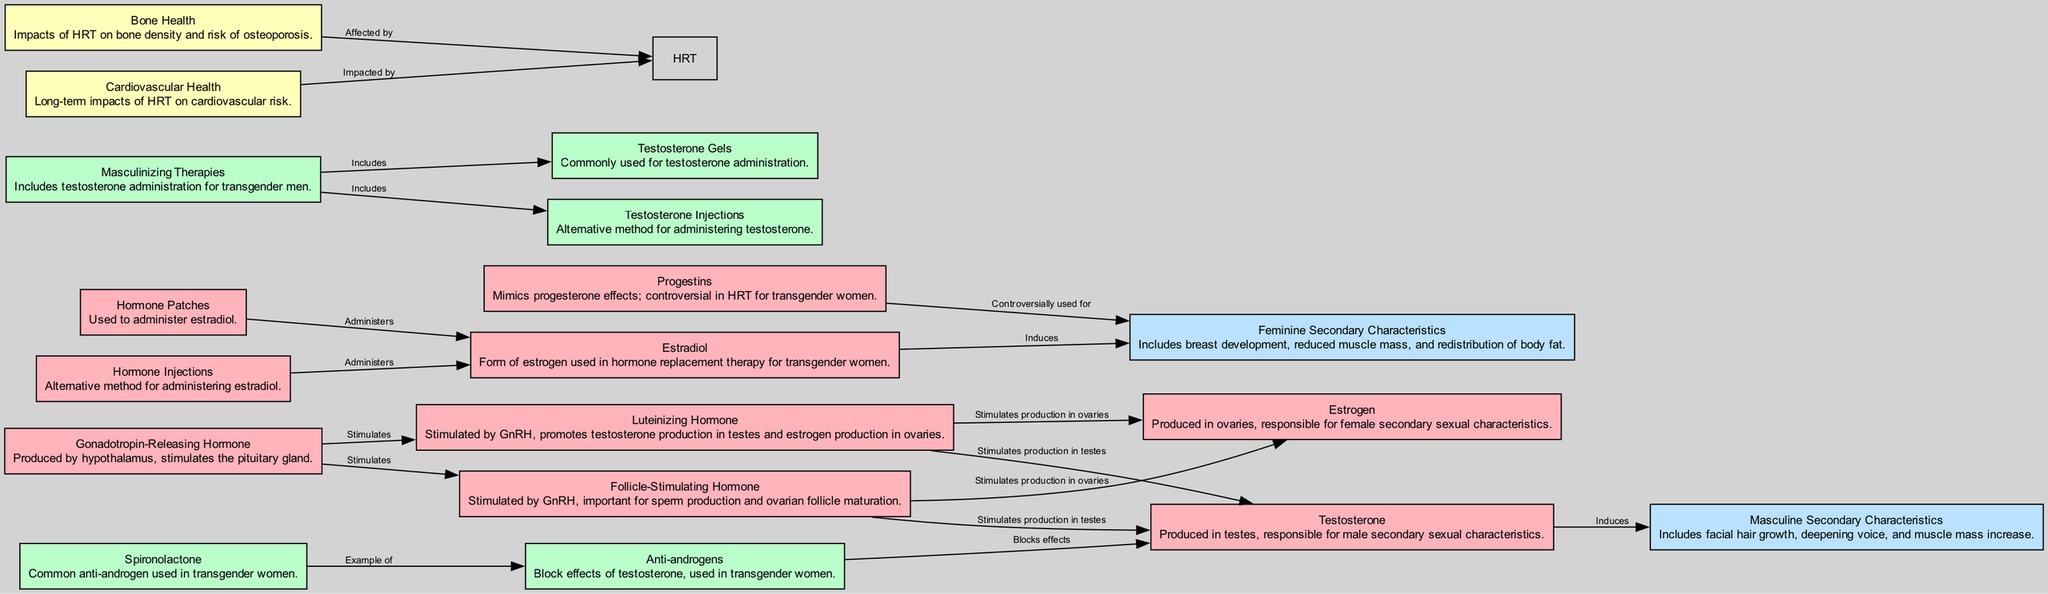What does GnRH stimulate? According to the diagram, GnRH (Gonadotropin-Releasing Hormone) has edges pointing to LH (Luteinizing Hormone) and FSH (Follicle-Stimulating Hormone), indicating that it stimulates both of these hormones.
Answer: LH and FSH How many hormones are administered in transgender women's therapy? The diagram shows two distinct methods for administering estradiol: hormone patches and hormone injections. This indicates there are at least two types of hormone therapy for transgender women.
Answer: Two Which hormone is blocked by anti-androgens? The diagram specifies that anti-androgens block the effects of testosterone, indicating their role in the therapy.
Answer: Testosterone What are the effects induced by estradiol? Estradiol has a direct connection in the diagram labeled "induces" leading to feminine changes, demonstrating its physiological effects in transgender women undergoing hormone replacement therapy.
Answer: Feminine Changes What is an example of an anti-androgen used? The diagram identifies spironolactone as a common example of an anti-androgen used in transgender women, highlighting its specific role in the therapy.
Answer: Spironolactone What secondary characteristics does testosterone induce? Testosterone is linked to the "Masculine Secondary Characteristics" in the diagram, indicating its role in inducing such features in transgender men undergoing masculinizing therapies.
Answer: Masculine Secondary Characteristics Which health aspect is impacted by HRT mentioned in the diagram? The diagram displays edges leading from Bone Health and Cardiovascular Health to HRT, indicating both aspects are affected as a result of hormone replacement therapy.
Answer: Bone Health and Cardiovascular Health What type of therapy includes testosterone gels? The diagram connects masculinizing therapies with testosterone gels, demonstrating that gels are a method included in masculinizing therapies for transgender men.
Answer: Masculinizing Therapies 